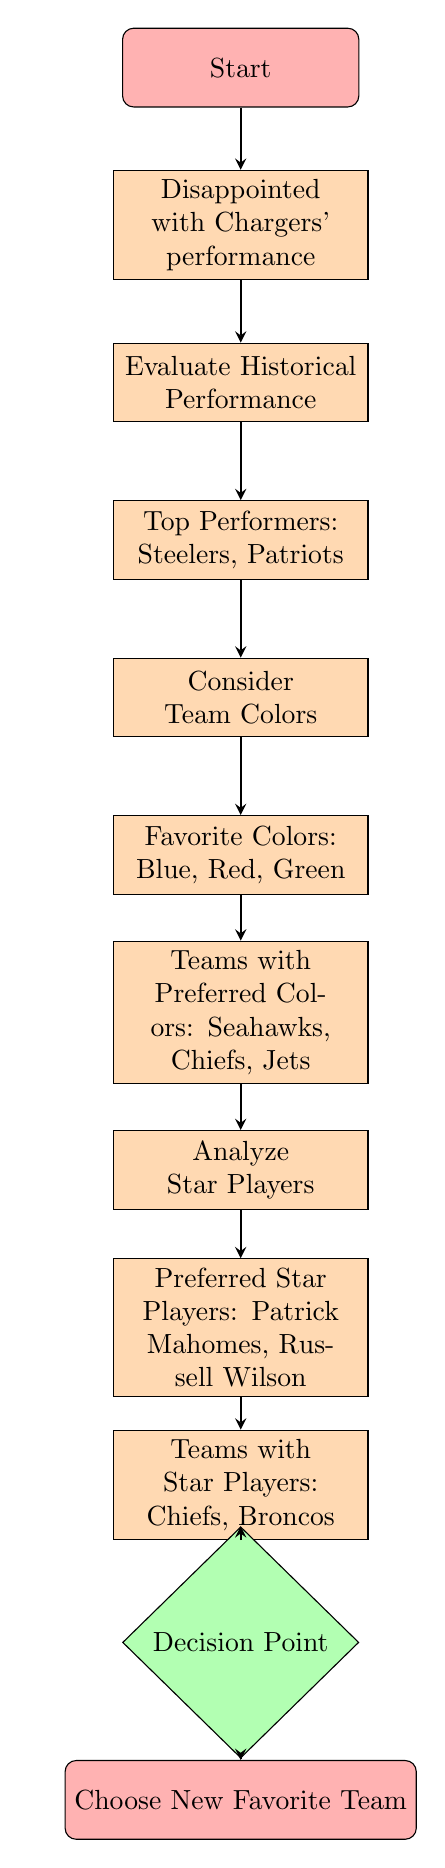What is the first node in the diagram? The first node in the diagram is labeled "Start", which indicates the beginning of the decision-making process.
Answer: Start How many nodes are there in total? By counting the nodes from "Start" to "Choose New Favorite Team," there are 12 nodes present in the diagram.
Answer: 12 What is the last step in the flowchart? The last step in the flowchart is "Choose New Favorite Team," which is where the decision-making process culminates.
Answer: Choose New Favorite Team Which teams are indicated as historical top performers? The node specifies "Top Performers: Steelers, Patriots," showing these teams as having strong historical performances.
Answer: Steelers, Patriots What determines the team colors you are considering? The node indicates "Favorite Colors: Blue, Red, Green," suggesting these are the criteria for considering team colors in the decision-making process.
Answer: Blue, Red, Green Which teams have star players according to the diagram? The diagram highlights "Teams with Star Players: Chiefs, Broncos," indicating these teams possess well-known star players.
Answer: Chiefs, Broncos What is the relationship between the teams with preferred colors and the star players? The flowchart links the "Teams with Preferred Colors" node to "Teams with Star Players," indicating how the evaluation of team colors and star players influences the decision.
Answer: They both influence team selection What is the decision point based on in the flowchart? The decision point considers the evaluations from historical performance, team colors, and star players before selecting a new favorite team.
Answer: Historical performance, team colors, star players What colors are preferred in this decision-making process? The preferred colors listed in the flowchart are "Blue, Red, Green," framing the choice of team colors in the decision.
Answer: Blue, Red, Green Which team color must match before selecting a new favorite team? The flowchart specifies that the team color must correspond to one of the preferred colors (blue, red, green) before making a selection.
Answer: Preferred colors 